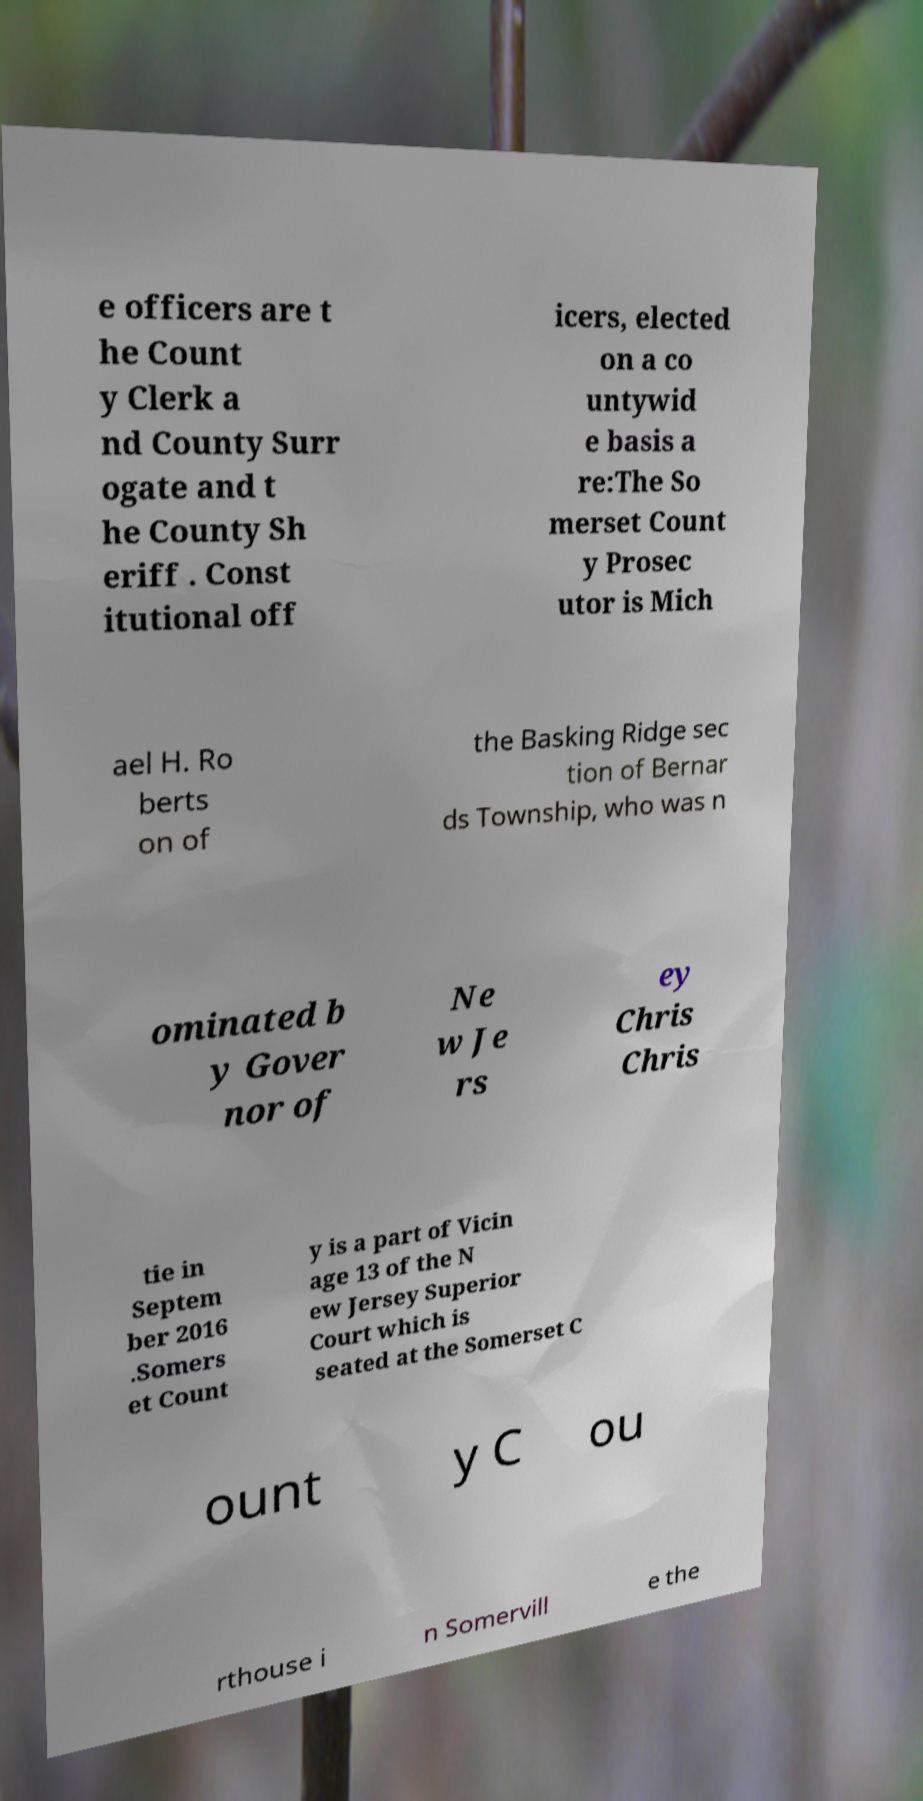Can you read and provide the text displayed in the image?This photo seems to have some interesting text. Can you extract and type it out for me? e officers are t he Count y Clerk a nd County Surr ogate and t he County Sh eriff . Const itutional off icers, elected on a co untywid e basis a re:The So merset Count y Prosec utor is Mich ael H. Ro berts on of the Basking Ridge sec tion of Bernar ds Township, who was n ominated b y Gover nor of Ne w Je rs ey Chris Chris tie in Septem ber 2016 .Somers et Count y is a part of Vicin age 13 of the N ew Jersey Superior Court which is seated at the Somerset C ount y C ou rthouse i n Somervill e the 